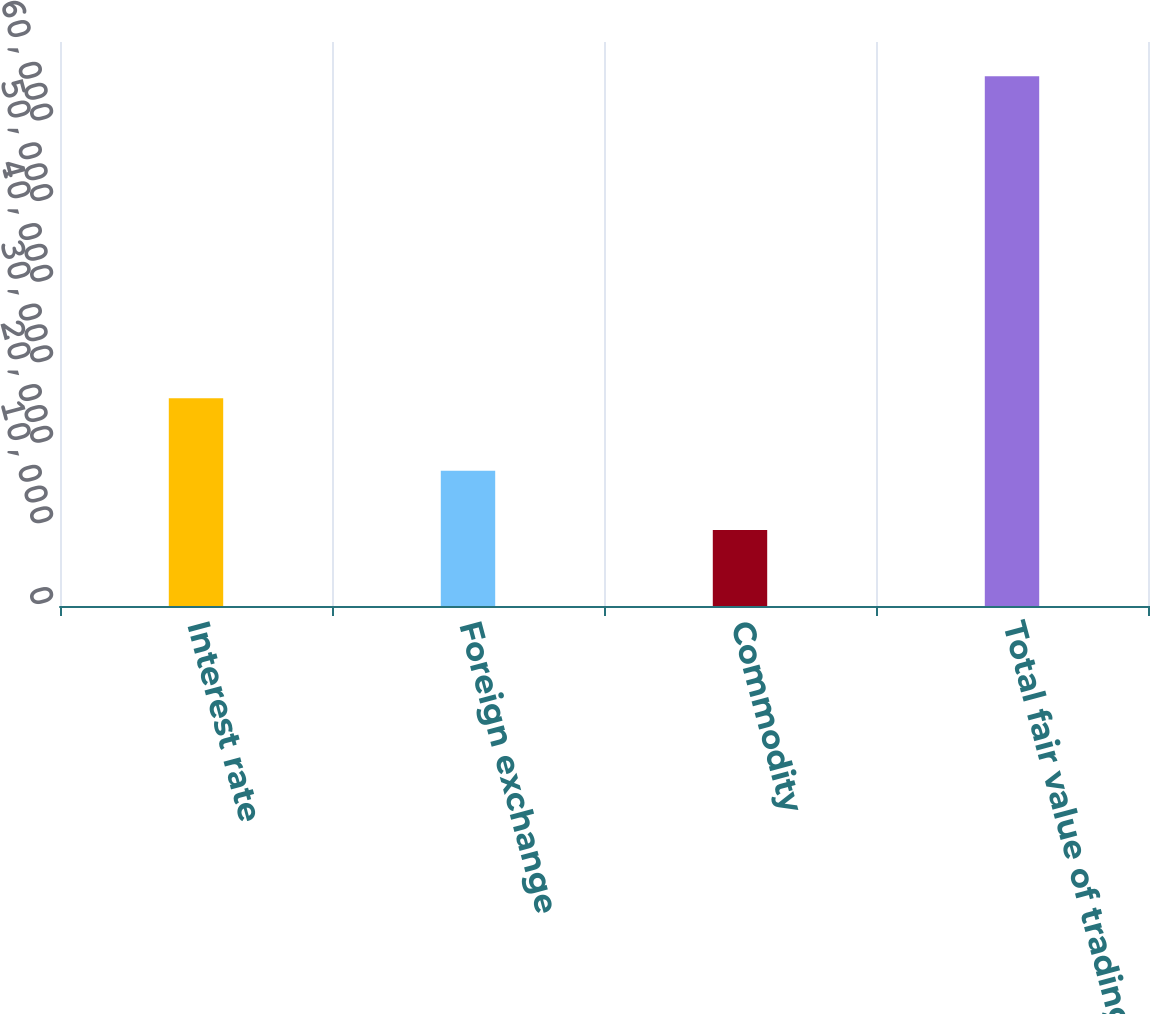<chart> <loc_0><loc_0><loc_500><loc_500><bar_chart><fcel>Interest rate<fcel>Foreign exchange<fcel>Commodity<fcel>Total fair value of trading<nl><fcel>25782<fcel>16790<fcel>9444<fcel>65759<nl></chart> 